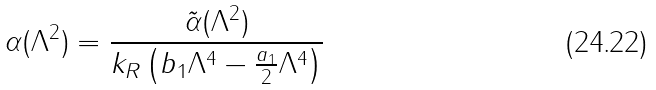Convert formula to latex. <formula><loc_0><loc_0><loc_500><loc_500>\alpha ( \Lambda ^ { 2 } ) = \frac { \tilde { \alpha } ( \Lambda ^ { 2 } ) } { k _ { R } \left ( b _ { 1 } \Lambda ^ { 4 } - \frac { a _ { 1 } } { 2 } \Lambda ^ { 4 } \right ) }</formula> 